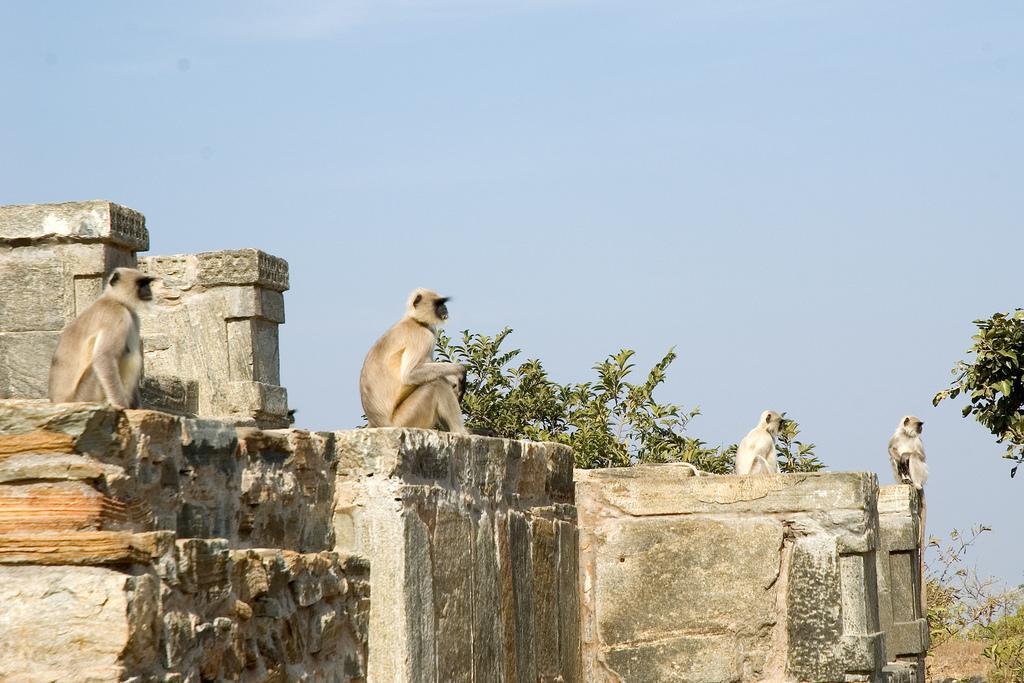Could you give a brief overview of what you see in this image? In this image, we can see monkeys on the rock and in the background, there are trees. At the top, there is sky. 